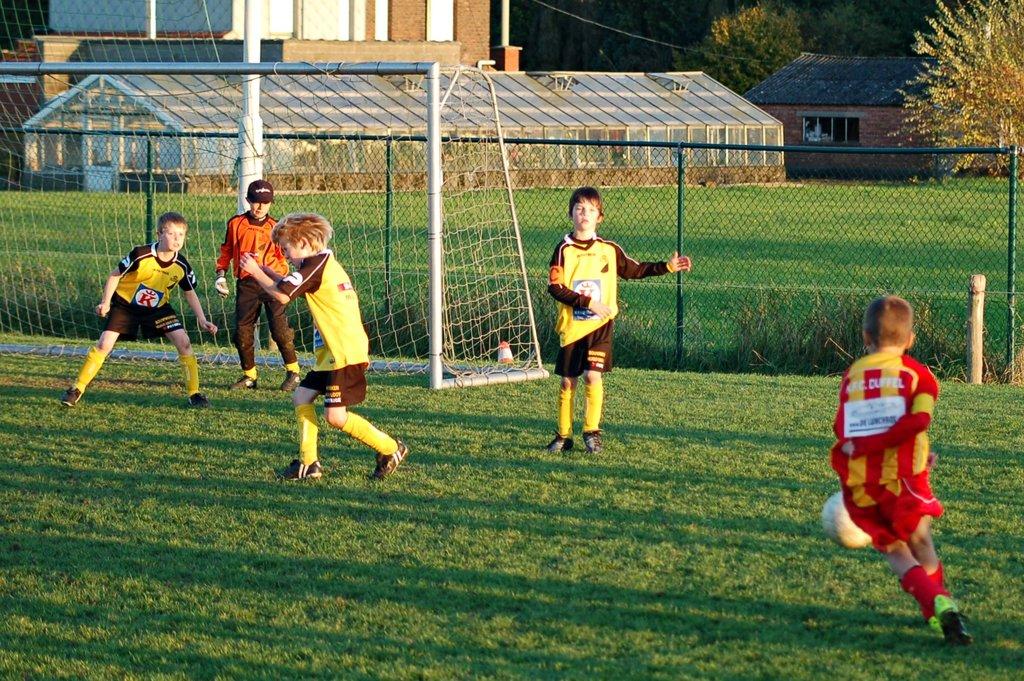What letter is seen on the front of the shirt of the boy in yellow near the goal?
Offer a terse response. K. 